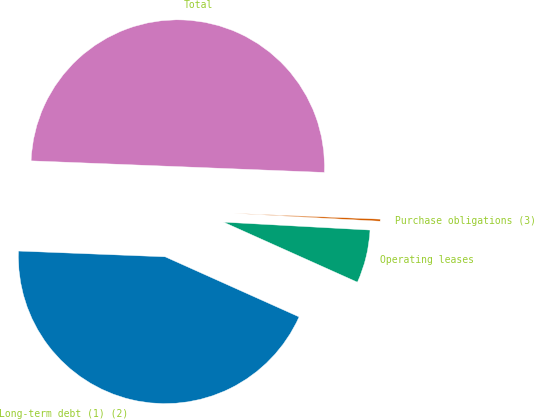Convert chart to OTSL. <chart><loc_0><loc_0><loc_500><loc_500><pie_chart><fcel>Long-term debt (1) (2)<fcel>Operating leases<fcel>Purchase obligations (3)<fcel>Total<nl><fcel>43.91%<fcel>5.85%<fcel>0.23%<fcel>50.0%<nl></chart> 